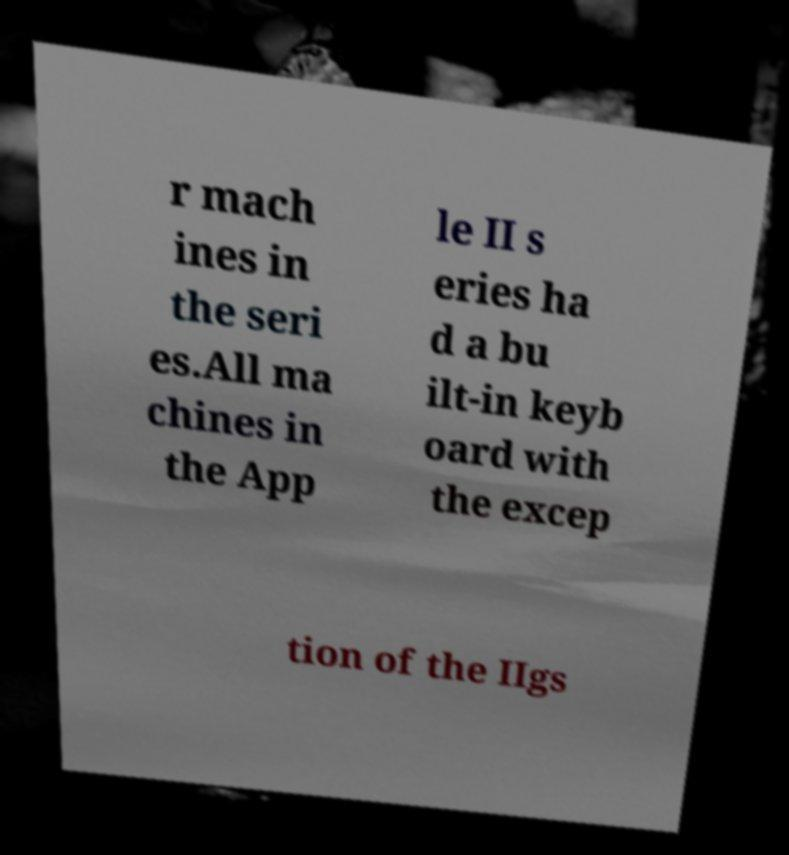Please read and relay the text visible in this image. What does it say? r mach ines in the seri es.All ma chines in the App le II s eries ha d a bu ilt-in keyb oard with the excep tion of the IIgs 